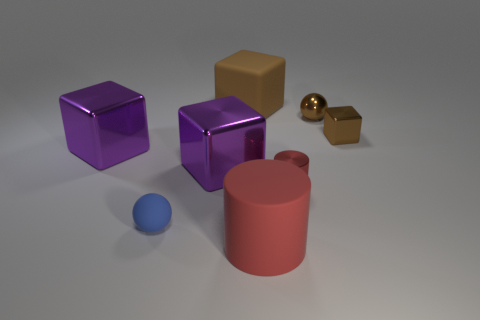Can you describe the objects in this image and their arrangement? Certainly! The image showcases five objects on a surface under diffuse lighting. There are two shiny purple cubes, one significantly larger than the other, and a small golden cube with a metallic sheen. Accompanying these cubes is a matte-textured brown cylindrical container with no lid, and a small, blue, flat-looking sphere that is likely made of rubber or plastic due to its matte finish and appearance of softness. 